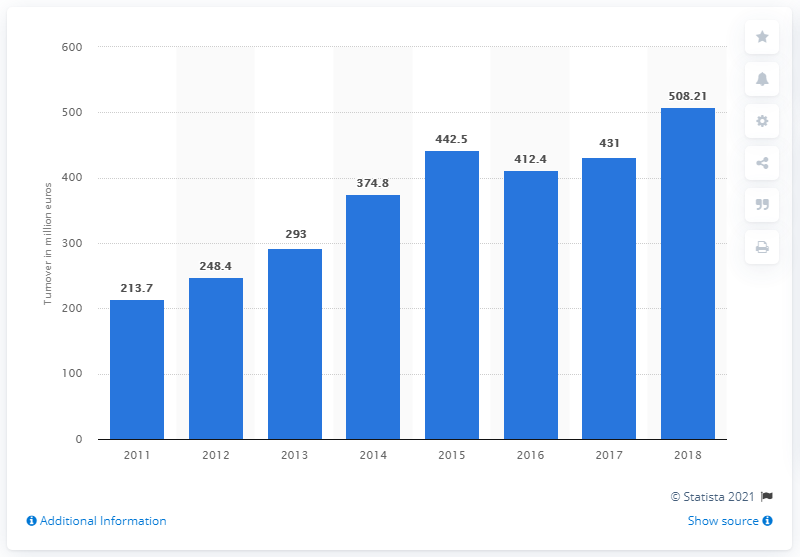Indicate a few pertinent items in this graphic. The turnover of Versace increased by 18.6% from 2016 to 2017. The turnover of Gianni Versace in 2011 was 213.7 million euros. In 2018, Versace achieved the highest turnover in its history. 